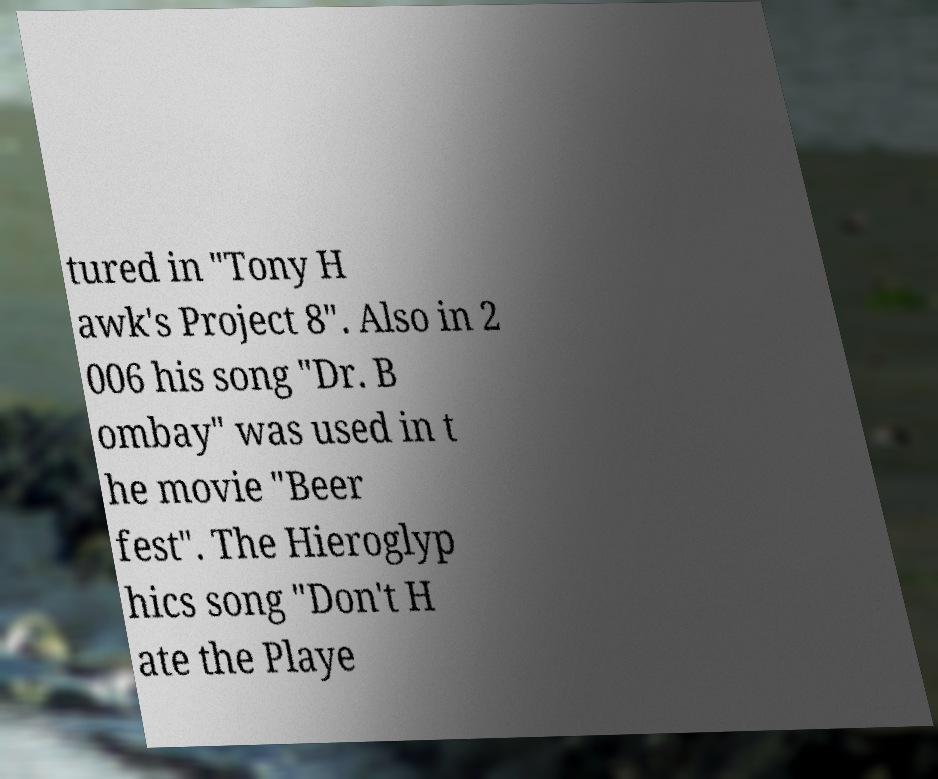Could you extract and type out the text from this image? tured in "Tony H awk's Project 8". Also in 2 006 his song "Dr. B ombay" was used in t he movie "Beer fest". The Hieroglyp hics song "Don't H ate the Playe 